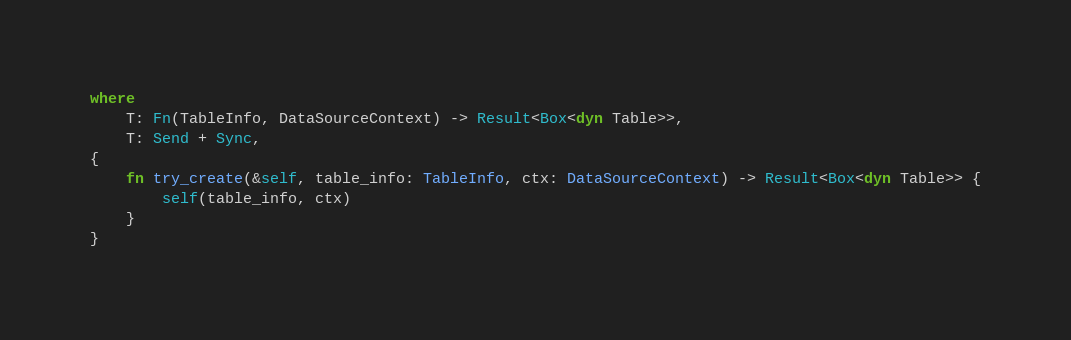Convert code to text. <code><loc_0><loc_0><loc_500><loc_500><_Rust_>where
    T: Fn(TableInfo, DataSourceContext) -> Result<Box<dyn Table>>,
    T: Send + Sync,
{
    fn try_create(&self, table_info: TableInfo, ctx: DataSourceContext) -> Result<Box<dyn Table>> {
        self(table_info, ctx)
    }
}
</code> 